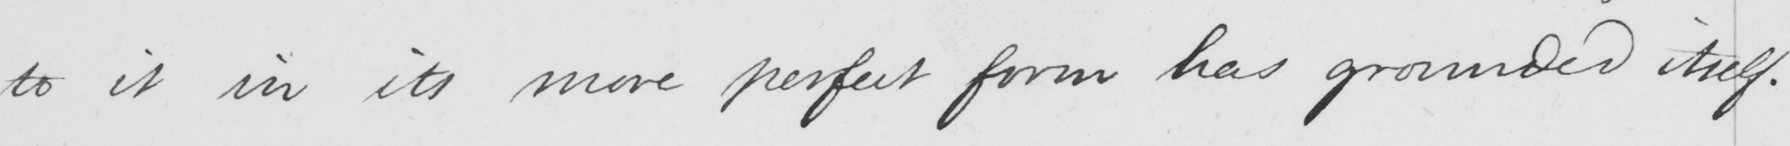What text is written in this handwritten line? to it in its more perfect form has grounded itself . 